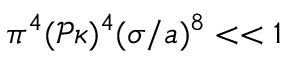<formula> <loc_0><loc_0><loc_500><loc_500>\pi ^ { 4 } ( \mathcal { P } \kappa ) ^ { 4 } ( \sigma / a ) ^ { 8 } < < 1</formula> 